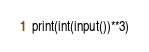<code> <loc_0><loc_0><loc_500><loc_500><_Python_>print(int(input())**3)
</code> 